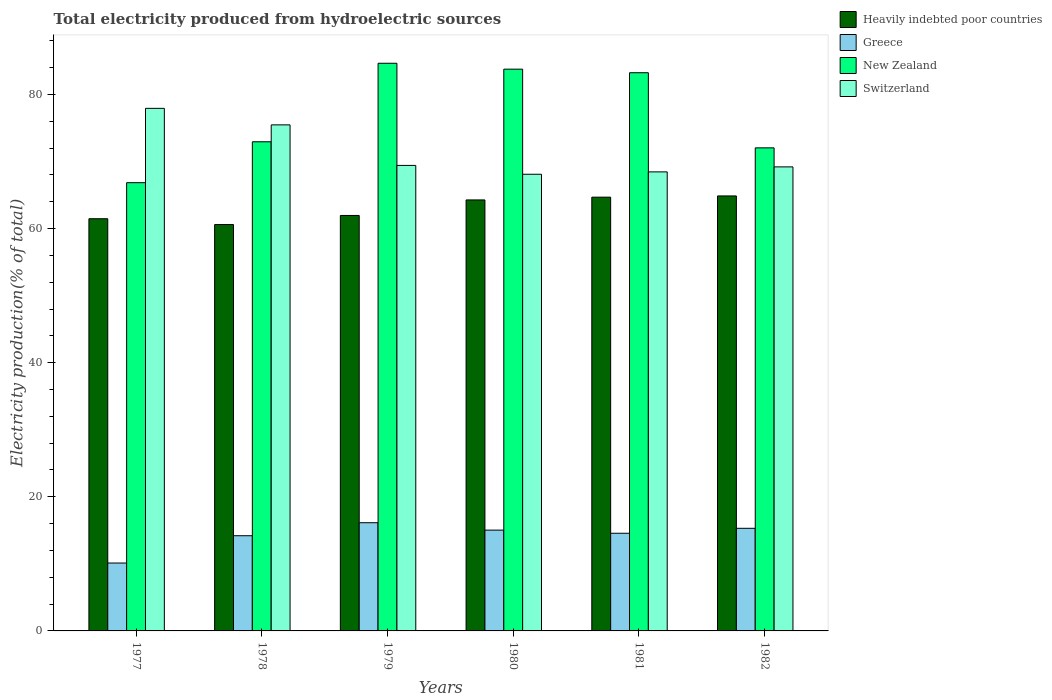Are the number of bars on each tick of the X-axis equal?
Your answer should be very brief. Yes. How many bars are there on the 1st tick from the right?
Give a very brief answer. 4. What is the label of the 2nd group of bars from the left?
Provide a short and direct response. 1978. In how many cases, is the number of bars for a given year not equal to the number of legend labels?
Make the answer very short. 0. What is the total electricity produced in Greece in 1981?
Provide a succinct answer. 14.56. Across all years, what is the maximum total electricity produced in New Zealand?
Offer a very short reply. 84.65. Across all years, what is the minimum total electricity produced in Heavily indebted poor countries?
Your response must be concise. 60.6. In which year was the total electricity produced in Switzerland maximum?
Provide a short and direct response. 1977. What is the total total electricity produced in New Zealand in the graph?
Keep it short and to the point. 463.47. What is the difference between the total electricity produced in Switzerland in 1977 and that in 1982?
Provide a succinct answer. 8.73. What is the difference between the total electricity produced in Greece in 1978 and the total electricity produced in Switzerland in 1980?
Provide a succinct answer. -53.9. What is the average total electricity produced in Heavily indebted poor countries per year?
Your answer should be compact. 62.97. In the year 1979, what is the difference between the total electricity produced in Heavily indebted poor countries and total electricity produced in New Zealand?
Keep it short and to the point. -22.7. In how many years, is the total electricity produced in Heavily indebted poor countries greater than 44 %?
Provide a short and direct response. 6. What is the ratio of the total electricity produced in Heavily indebted poor countries in 1981 to that in 1982?
Ensure brevity in your answer.  1. What is the difference between the highest and the second highest total electricity produced in Greece?
Offer a terse response. 0.83. What is the difference between the highest and the lowest total electricity produced in Greece?
Provide a short and direct response. 6.01. Is it the case that in every year, the sum of the total electricity produced in Switzerland and total electricity produced in New Zealand is greater than the sum of total electricity produced in Greece and total electricity produced in Heavily indebted poor countries?
Offer a very short reply. No. What does the 4th bar from the left in 1979 represents?
Provide a short and direct response. Switzerland. What does the 4th bar from the right in 1981 represents?
Make the answer very short. Heavily indebted poor countries. Is it the case that in every year, the sum of the total electricity produced in Heavily indebted poor countries and total electricity produced in Switzerland is greater than the total electricity produced in New Zealand?
Your response must be concise. Yes. Are all the bars in the graph horizontal?
Provide a succinct answer. No. How many years are there in the graph?
Provide a succinct answer. 6. Does the graph contain any zero values?
Your answer should be compact. No. Does the graph contain grids?
Your answer should be compact. No. Where does the legend appear in the graph?
Provide a succinct answer. Top right. How are the legend labels stacked?
Ensure brevity in your answer.  Vertical. What is the title of the graph?
Keep it short and to the point. Total electricity produced from hydroelectric sources. What is the Electricity production(% of total) in Heavily indebted poor countries in 1977?
Offer a terse response. 61.46. What is the Electricity production(% of total) in Greece in 1977?
Give a very brief answer. 10.12. What is the Electricity production(% of total) of New Zealand in 1977?
Offer a terse response. 66.84. What is the Electricity production(% of total) of Switzerland in 1977?
Ensure brevity in your answer.  77.92. What is the Electricity production(% of total) of Heavily indebted poor countries in 1978?
Give a very brief answer. 60.6. What is the Electricity production(% of total) of Greece in 1978?
Make the answer very short. 14.19. What is the Electricity production(% of total) of New Zealand in 1978?
Provide a succinct answer. 72.94. What is the Electricity production(% of total) of Switzerland in 1978?
Your answer should be very brief. 75.46. What is the Electricity production(% of total) in Heavily indebted poor countries in 1979?
Ensure brevity in your answer.  61.95. What is the Electricity production(% of total) in Greece in 1979?
Offer a very short reply. 16.13. What is the Electricity production(% of total) in New Zealand in 1979?
Provide a succinct answer. 84.65. What is the Electricity production(% of total) in Switzerland in 1979?
Your answer should be compact. 69.41. What is the Electricity production(% of total) in Heavily indebted poor countries in 1980?
Your answer should be compact. 64.27. What is the Electricity production(% of total) of Greece in 1980?
Give a very brief answer. 15.03. What is the Electricity production(% of total) of New Zealand in 1980?
Your response must be concise. 83.77. What is the Electricity production(% of total) in Switzerland in 1980?
Offer a terse response. 68.1. What is the Electricity production(% of total) of Heavily indebted poor countries in 1981?
Ensure brevity in your answer.  64.68. What is the Electricity production(% of total) in Greece in 1981?
Make the answer very short. 14.56. What is the Electricity production(% of total) in New Zealand in 1981?
Your answer should be compact. 83.24. What is the Electricity production(% of total) of Switzerland in 1981?
Your response must be concise. 68.45. What is the Electricity production(% of total) of Heavily indebted poor countries in 1982?
Ensure brevity in your answer.  64.86. What is the Electricity production(% of total) in Greece in 1982?
Ensure brevity in your answer.  15.3. What is the Electricity production(% of total) in New Zealand in 1982?
Offer a terse response. 72.03. What is the Electricity production(% of total) of Switzerland in 1982?
Make the answer very short. 69.2. Across all years, what is the maximum Electricity production(% of total) in Heavily indebted poor countries?
Your response must be concise. 64.86. Across all years, what is the maximum Electricity production(% of total) in Greece?
Make the answer very short. 16.13. Across all years, what is the maximum Electricity production(% of total) in New Zealand?
Your answer should be compact. 84.65. Across all years, what is the maximum Electricity production(% of total) in Switzerland?
Your response must be concise. 77.92. Across all years, what is the minimum Electricity production(% of total) in Heavily indebted poor countries?
Make the answer very short. 60.6. Across all years, what is the minimum Electricity production(% of total) in Greece?
Your response must be concise. 10.12. Across all years, what is the minimum Electricity production(% of total) in New Zealand?
Keep it short and to the point. 66.84. Across all years, what is the minimum Electricity production(% of total) of Switzerland?
Provide a succinct answer. 68.1. What is the total Electricity production(% of total) of Heavily indebted poor countries in the graph?
Offer a very short reply. 377.83. What is the total Electricity production(% of total) in Greece in the graph?
Your answer should be very brief. 85.35. What is the total Electricity production(% of total) in New Zealand in the graph?
Your answer should be compact. 463.47. What is the total Electricity production(% of total) in Switzerland in the graph?
Your answer should be very brief. 428.54. What is the difference between the Electricity production(% of total) of Heavily indebted poor countries in 1977 and that in 1978?
Your answer should be very brief. 0.87. What is the difference between the Electricity production(% of total) in Greece in 1977 and that in 1978?
Provide a short and direct response. -4.07. What is the difference between the Electricity production(% of total) of New Zealand in 1977 and that in 1978?
Provide a short and direct response. -6.1. What is the difference between the Electricity production(% of total) in Switzerland in 1977 and that in 1978?
Your response must be concise. 2.46. What is the difference between the Electricity production(% of total) of Heavily indebted poor countries in 1977 and that in 1979?
Offer a very short reply. -0.49. What is the difference between the Electricity production(% of total) of Greece in 1977 and that in 1979?
Provide a succinct answer. -6.01. What is the difference between the Electricity production(% of total) of New Zealand in 1977 and that in 1979?
Your answer should be very brief. -17.81. What is the difference between the Electricity production(% of total) in Switzerland in 1977 and that in 1979?
Give a very brief answer. 8.51. What is the difference between the Electricity production(% of total) in Heavily indebted poor countries in 1977 and that in 1980?
Provide a short and direct response. -2.8. What is the difference between the Electricity production(% of total) in Greece in 1977 and that in 1980?
Your response must be concise. -4.91. What is the difference between the Electricity production(% of total) in New Zealand in 1977 and that in 1980?
Provide a short and direct response. -16.93. What is the difference between the Electricity production(% of total) in Switzerland in 1977 and that in 1980?
Give a very brief answer. 9.83. What is the difference between the Electricity production(% of total) of Heavily indebted poor countries in 1977 and that in 1981?
Your response must be concise. -3.22. What is the difference between the Electricity production(% of total) in Greece in 1977 and that in 1981?
Ensure brevity in your answer.  -4.44. What is the difference between the Electricity production(% of total) in New Zealand in 1977 and that in 1981?
Your answer should be very brief. -16.4. What is the difference between the Electricity production(% of total) in Switzerland in 1977 and that in 1981?
Your answer should be compact. 9.47. What is the difference between the Electricity production(% of total) in Heavily indebted poor countries in 1977 and that in 1982?
Offer a very short reply. -3.4. What is the difference between the Electricity production(% of total) in Greece in 1977 and that in 1982?
Provide a short and direct response. -5.18. What is the difference between the Electricity production(% of total) of New Zealand in 1977 and that in 1982?
Provide a succinct answer. -5.19. What is the difference between the Electricity production(% of total) in Switzerland in 1977 and that in 1982?
Keep it short and to the point. 8.73. What is the difference between the Electricity production(% of total) in Heavily indebted poor countries in 1978 and that in 1979?
Give a very brief answer. -1.35. What is the difference between the Electricity production(% of total) in Greece in 1978 and that in 1979?
Make the answer very short. -1.94. What is the difference between the Electricity production(% of total) of New Zealand in 1978 and that in 1979?
Provide a succinct answer. -11.71. What is the difference between the Electricity production(% of total) of Switzerland in 1978 and that in 1979?
Ensure brevity in your answer.  6.05. What is the difference between the Electricity production(% of total) in Heavily indebted poor countries in 1978 and that in 1980?
Offer a terse response. -3.67. What is the difference between the Electricity production(% of total) of Greece in 1978 and that in 1980?
Provide a succinct answer. -0.84. What is the difference between the Electricity production(% of total) of New Zealand in 1978 and that in 1980?
Your answer should be very brief. -10.83. What is the difference between the Electricity production(% of total) in Switzerland in 1978 and that in 1980?
Your answer should be very brief. 7.36. What is the difference between the Electricity production(% of total) of Heavily indebted poor countries in 1978 and that in 1981?
Offer a terse response. -4.08. What is the difference between the Electricity production(% of total) in Greece in 1978 and that in 1981?
Your answer should be very brief. -0.37. What is the difference between the Electricity production(% of total) of New Zealand in 1978 and that in 1981?
Keep it short and to the point. -10.3. What is the difference between the Electricity production(% of total) of Switzerland in 1978 and that in 1981?
Your response must be concise. 7.01. What is the difference between the Electricity production(% of total) of Heavily indebted poor countries in 1978 and that in 1982?
Provide a short and direct response. -4.27. What is the difference between the Electricity production(% of total) of Greece in 1978 and that in 1982?
Provide a short and direct response. -1.11. What is the difference between the Electricity production(% of total) of New Zealand in 1978 and that in 1982?
Ensure brevity in your answer.  0.9. What is the difference between the Electricity production(% of total) of Switzerland in 1978 and that in 1982?
Ensure brevity in your answer.  6.27. What is the difference between the Electricity production(% of total) in Heavily indebted poor countries in 1979 and that in 1980?
Offer a terse response. -2.32. What is the difference between the Electricity production(% of total) in Greece in 1979 and that in 1980?
Your answer should be compact. 1.1. What is the difference between the Electricity production(% of total) in New Zealand in 1979 and that in 1980?
Keep it short and to the point. 0.88. What is the difference between the Electricity production(% of total) of Switzerland in 1979 and that in 1980?
Provide a short and direct response. 1.32. What is the difference between the Electricity production(% of total) in Heavily indebted poor countries in 1979 and that in 1981?
Provide a short and direct response. -2.73. What is the difference between the Electricity production(% of total) of Greece in 1979 and that in 1981?
Offer a very short reply. 1.57. What is the difference between the Electricity production(% of total) of New Zealand in 1979 and that in 1981?
Provide a succinct answer. 1.41. What is the difference between the Electricity production(% of total) of Switzerland in 1979 and that in 1981?
Ensure brevity in your answer.  0.96. What is the difference between the Electricity production(% of total) of Heavily indebted poor countries in 1979 and that in 1982?
Make the answer very short. -2.91. What is the difference between the Electricity production(% of total) of Greece in 1979 and that in 1982?
Your answer should be compact. 0.83. What is the difference between the Electricity production(% of total) of New Zealand in 1979 and that in 1982?
Offer a very short reply. 12.61. What is the difference between the Electricity production(% of total) of Switzerland in 1979 and that in 1982?
Your answer should be very brief. 0.22. What is the difference between the Electricity production(% of total) of Heavily indebted poor countries in 1980 and that in 1981?
Your answer should be very brief. -0.41. What is the difference between the Electricity production(% of total) in Greece in 1980 and that in 1981?
Give a very brief answer. 0.47. What is the difference between the Electricity production(% of total) in New Zealand in 1980 and that in 1981?
Your response must be concise. 0.53. What is the difference between the Electricity production(% of total) in Switzerland in 1980 and that in 1981?
Offer a very short reply. -0.36. What is the difference between the Electricity production(% of total) of Heavily indebted poor countries in 1980 and that in 1982?
Offer a very short reply. -0.59. What is the difference between the Electricity production(% of total) in Greece in 1980 and that in 1982?
Ensure brevity in your answer.  -0.27. What is the difference between the Electricity production(% of total) of New Zealand in 1980 and that in 1982?
Your answer should be compact. 11.73. What is the difference between the Electricity production(% of total) of Switzerland in 1980 and that in 1982?
Give a very brief answer. -1.1. What is the difference between the Electricity production(% of total) in Heavily indebted poor countries in 1981 and that in 1982?
Make the answer very short. -0.18. What is the difference between the Electricity production(% of total) in Greece in 1981 and that in 1982?
Your response must be concise. -0.74. What is the difference between the Electricity production(% of total) in New Zealand in 1981 and that in 1982?
Provide a short and direct response. 11.2. What is the difference between the Electricity production(% of total) in Switzerland in 1981 and that in 1982?
Ensure brevity in your answer.  -0.74. What is the difference between the Electricity production(% of total) of Heavily indebted poor countries in 1977 and the Electricity production(% of total) of Greece in 1978?
Offer a very short reply. 47.27. What is the difference between the Electricity production(% of total) in Heavily indebted poor countries in 1977 and the Electricity production(% of total) in New Zealand in 1978?
Your response must be concise. -11.47. What is the difference between the Electricity production(% of total) in Heavily indebted poor countries in 1977 and the Electricity production(% of total) in Switzerland in 1978?
Your response must be concise. -14. What is the difference between the Electricity production(% of total) in Greece in 1977 and the Electricity production(% of total) in New Zealand in 1978?
Offer a very short reply. -62.82. What is the difference between the Electricity production(% of total) in Greece in 1977 and the Electricity production(% of total) in Switzerland in 1978?
Make the answer very short. -65.34. What is the difference between the Electricity production(% of total) of New Zealand in 1977 and the Electricity production(% of total) of Switzerland in 1978?
Provide a short and direct response. -8.62. What is the difference between the Electricity production(% of total) of Heavily indebted poor countries in 1977 and the Electricity production(% of total) of Greece in 1979?
Offer a terse response. 45.33. What is the difference between the Electricity production(% of total) in Heavily indebted poor countries in 1977 and the Electricity production(% of total) in New Zealand in 1979?
Offer a terse response. -23.18. What is the difference between the Electricity production(% of total) of Heavily indebted poor countries in 1977 and the Electricity production(% of total) of Switzerland in 1979?
Give a very brief answer. -7.95. What is the difference between the Electricity production(% of total) in Greece in 1977 and the Electricity production(% of total) in New Zealand in 1979?
Ensure brevity in your answer.  -74.52. What is the difference between the Electricity production(% of total) of Greece in 1977 and the Electricity production(% of total) of Switzerland in 1979?
Ensure brevity in your answer.  -59.29. What is the difference between the Electricity production(% of total) of New Zealand in 1977 and the Electricity production(% of total) of Switzerland in 1979?
Keep it short and to the point. -2.57. What is the difference between the Electricity production(% of total) in Heavily indebted poor countries in 1977 and the Electricity production(% of total) in Greece in 1980?
Provide a succinct answer. 46.43. What is the difference between the Electricity production(% of total) in Heavily indebted poor countries in 1977 and the Electricity production(% of total) in New Zealand in 1980?
Your answer should be very brief. -22.3. What is the difference between the Electricity production(% of total) in Heavily indebted poor countries in 1977 and the Electricity production(% of total) in Switzerland in 1980?
Your response must be concise. -6.63. What is the difference between the Electricity production(% of total) of Greece in 1977 and the Electricity production(% of total) of New Zealand in 1980?
Make the answer very short. -73.64. What is the difference between the Electricity production(% of total) of Greece in 1977 and the Electricity production(% of total) of Switzerland in 1980?
Make the answer very short. -57.97. What is the difference between the Electricity production(% of total) in New Zealand in 1977 and the Electricity production(% of total) in Switzerland in 1980?
Your response must be concise. -1.25. What is the difference between the Electricity production(% of total) in Heavily indebted poor countries in 1977 and the Electricity production(% of total) in Greece in 1981?
Offer a very short reply. 46.9. What is the difference between the Electricity production(% of total) of Heavily indebted poor countries in 1977 and the Electricity production(% of total) of New Zealand in 1981?
Provide a succinct answer. -21.77. What is the difference between the Electricity production(% of total) of Heavily indebted poor countries in 1977 and the Electricity production(% of total) of Switzerland in 1981?
Make the answer very short. -6.99. What is the difference between the Electricity production(% of total) of Greece in 1977 and the Electricity production(% of total) of New Zealand in 1981?
Give a very brief answer. -73.11. What is the difference between the Electricity production(% of total) of Greece in 1977 and the Electricity production(% of total) of Switzerland in 1981?
Your answer should be compact. -58.33. What is the difference between the Electricity production(% of total) in New Zealand in 1977 and the Electricity production(% of total) in Switzerland in 1981?
Make the answer very short. -1.61. What is the difference between the Electricity production(% of total) of Heavily indebted poor countries in 1977 and the Electricity production(% of total) of Greece in 1982?
Your answer should be compact. 46.16. What is the difference between the Electricity production(% of total) of Heavily indebted poor countries in 1977 and the Electricity production(% of total) of New Zealand in 1982?
Offer a terse response. -10.57. What is the difference between the Electricity production(% of total) of Heavily indebted poor countries in 1977 and the Electricity production(% of total) of Switzerland in 1982?
Your answer should be compact. -7.73. What is the difference between the Electricity production(% of total) of Greece in 1977 and the Electricity production(% of total) of New Zealand in 1982?
Ensure brevity in your answer.  -61.91. What is the difference between the Electricity production(% of total) of Greece in 1977 and the Electricity production(% of total) of Switzerland in 1982?
Your response must be concise. -59.07. What is the difference between the Electricity production(% of total) of New Zealand in 1977 and the Electricity production(% of total) of Switzerland in 1982?
Keep it short and to the point. -2.35. What is the difference between the Electricity production(% of total) in Heavily indebted poor countries in 1978 and the Electricity production(% of total) in Greece in 1979?
Ensure brevity in your answer.  44.46. What is the difference between the Electricity production(% of total) in Heavily indebted poor countries in 1978 and the Electricity production(% of total) in New Zealand in 1979?
Make the answer very short. -24.05. What is the difference between the Electricity production(% of total) in Heavily indebted poor countries in 1978 and the Electricity production(% of total) in Switzerland in 1979?
Offer a terse response. -8.82. What is the difference between the Electricity production(% of total) in Greece in 1978 and the Electricity production(% of total) in New Zealand in 1979?
Provide a succinct answer. -70.45. What is the difference between the Electricity production(% of total) in Greece in 1978 and the Electricity production(% of total) in Switzerland in 1979?
Make the answer very short. -55.22. What is the difference between the Electricity production(% of total) in New Zealand in 1978 and the Electricity production(% of total) in Switzerland in 1979?
Provide a succinct answer. 3.53. What is the difference between the Electricity production(% of total) of Heavily indebted poor countries in 1978 and the Electricity production(% of total) of Greece in 1980?
Make the answer very short. 45.57. What is the difference between the Electricity production(% of total) in Heavily indebted poor countries in 1978 and the Electricity production(% of total) in New Zealand in 1980?
Your response must be concise. -23.17. What is the difference between the Electricity production(% of total) in Heavily indebted poor countries in 1978 and the Electricity production(% of total) in Switzerland in 1980?
Make the answer very short. -7.5. What is the difference between the Electricity production(% of total) of Greece in 1978 and the Electricity production(% of total) of New Zealand in 1980?
Your answer should be compact. -69.57. What is the difference between the Electricity production(% of total) of Greece in 1978 and the Electricity production(% of total) of Switzerland in 1980?
Your answer should be very brief. -53.9. What is the difference between the Electricity production(% of total) in New Zealand in 1978 and the Electricity production(% of total) in Switzerland in 1980?
Give a very brief answer. 4.84. What is the difference between the Electricity production(% of total) in Heavily indebted poor countries in 1978 and the Electricity production(% of total) in Greece in 1981?
Ensure brevity in your answer.  46.03. What is the difference between the Electricity production(% of total) of Heavily indebted poor countries in 1978 and the Electricity production(% of total) of New Zealand in 1981?
Your answer should be compact. -22.64. What is the difference between the Electricity production(% of total) of Heavily indebted poor countries in 1978 and the Electricity production(% of total) of Switzerland in 1981?
Ensure brevity in your answer.  -7.85. What is the difference between the Electricity production(% of total) in Greece in 1978 and the Electricity production(% of total) in New Zealand in 1981?
Provide a succinct answer. -69.04. What is the difference between the Electricity production(% of total) of Greece in 1978 and the Electricity production(% of total) of Switzerland in 1981?
Your answer should be compact. -54.26. What is the difference between the Electricity production(% of total) in New Zealand in 1978 and the Electricity production(% of total) in Switzerland in 1981?
Your response must be concise. 4.49. What is the difference between the Electricity production(% of total) in Heavily indebted poor countries in 1978 and the Electricity production(% of total) in Greece in 1982?
Keep it short and to the point. 45.3. What is the difference between the Electricity production(% of total) of Heavily indebted poor countries in 1978 and the Electricity production(% of total) of New Zealand in 1982?
Provide a short and direct response. -11.44. What is the difference between the Electricity production(% of total) of Heavily indebted poor countries in 1978 and the Electricity production(% of total) of Switzerland in 1982?
Offer a very short reply. -8.6. What is the difference between the Electricity production(% of total) of Greece in 1978 and the Electricity production(% of total) of New Zealand in 1982?
Your response must be concise. -57.84. What is the difference between the Electricity production(% of total) of Greece in 1978 and the Electricity production(% of total) of Switzerland in 1982?
Offer a terse response. -55. What is the difference between the Electricity production(% of total) in New Zealand in 1978 and the Electricity production(% of total) in Switzerland in 1982?
Give a very brief answer. 3.74. What is the difference between the Electricity production(% of total) of Heavily indebted poor countries in 1979 and the Electricity production(% of total) of Greece in 1980?
Offer a very short reply. 46.92. What is the difference between the Electricity production(% of total) in Heavily indebted poor countries in 1979 and the Electricity production(% of total) in New Zealand in 1980?
Your answer should be very brief. -21.82. What is the difference between the Electricity production(% of total) in Heavily indebted poor countries in 1979 and the Electricity production(% of total) in Switzerland in 1980?
Make the answer very short. -6.14. What is the difference between the Electricity production(% of total) of Greece in 1979 and the Electricity production(% of total) of New Zealand in 1980?
Your response must be concise. -67.63. What is the difference between the Electricity production(% of total) in Greece in 1979 and the Electricity production(% of total) in Switzerland in 1980?
Provide a short and direct response. -51.96. What is the difference between the Electricity production(% of total) of New Zealand in 1979 and the Electricity production(% of total) of Switzerland in 1980?
Provide a succinct answer. 16.55. What is the difference between the Electricity production(% of total) of Heavily indebted poor countries in 1979 and the Electricity production(% of total) of Greece in 1981?
Your response must be concise. 47.39. What is the difference between the Electricity production(% of total) in Heavily indebted poor countries in 1979 and the Electricity production(% of total) in New Zealand in 1981?
Your answer should be very brief. -21.28. What is the difference between the Electricity production(% of total) of Heavily indebted poor countries in 1979 and the Electricity production(% of total) of Switzerland in 1981?
Give a very brief answer. -6.5. What is the difference between the Electricity production(% of total) of Greece in 1979 and the Electricity production(% of total) of New Zealand in 1981?
Your answer should be very brief. -67.1. What is the difference between the Electricity production(% of total) in Greece in 1979 and the Electricity production(% of total) in Switzerland in 1981?
Your answer should be compact. -52.32. What is the difference between the Electricity production(% of total) in New Zealand in 1979 and the Electricity production(% of total) in Switzerland in 1981?
Ensure brevity in your answer.  16.2. What is the difference between the Electricity production(% of total) of Heavily indebted poor countries in 1979 and the Electricity production(% of total) of Greece in 1982?
Give a very brief answer. 46.65. What is the difference between the Electricity production(% of total) of Heavily indebted poor countries in 1979 and the Electricity production(% of total) of New Zealand in 1982?
Your answer should be very brief. -10.08. What is the difference between the Electricity production(% of total) in Heavily indebted poor countries in 1979 and the Electricity production(% of total) in Switzerland in 1982?
Your response must be concise. -7.24. What is the difference between the Electricity production(% of total) in Greece in 1979 and the Electricity production(% of total) in New Zealand in 1982?
Make the answer very short. -55.9. What is the difference between the Electricity production(% of total) of Greece in 1979 and the Electricity production(% of total) of Switzerland in 1982?
Your response must be concise. -53.06. What is the difference between the Electricity production(% of total) of New Zealand in 1979 and the Electricity production(% of total) of Switzerland in 1982?
Make the answer very short. 15.45. What is the difference between the Electricity production(% of total) of Heavily indebted poor countries in 1980 and the Electricity production(% of total) of Greece in 1981?
Offer a terse response. 49.7. What is the difference between the Electricity production(% of total) of Heavily indebted poor countries in 1980 and the Electricity production(% of total) of New Zealand in 1981?
Keep it short and to the point. -18.97. What is the difference between the Electricity production(% of total) in Heavily indebted poor countries in 1980 and the Electricity production(% of total) in Switzerland in 1981?
Your response must be concise. -4.18. What is the difference between the Electricity production(% of total) of Greece in 1980 and the Electricity production(% of total) of New Zealand in 1981?
Ensure brevity in your answer.  -68.21. What is the difference between the Electricity production(% of total) of Greece in 1980 and the Electricity production(% of total) of Switzerland in 1981?
Offer a very short reply. -53.42. What is the difference between the Electricity production(% of total) in New Zealand in 1980 and the Electricity production(% of total) in Switzerland in 1981?
Give a very brief answer. 15.32. What is the difference between the Electricity production(% of total) of Heavily indebted poor countries in 1980 and the Electricity production(% of total) of Greece in 1982?
Keep it short and to the point. 48.97. What is the difference between the Electricity production(% of total) of Heavily indebted poor countries in 1980 and the Electricity production(% of total) of New Zealand in 1982?
Make the answer very short. -7.77. What is the difference between the Electricity production(% of total) of Heavily indebted poor countries in 1980 and the Electricity production(% of total) of Switzerland in 1982?
Give a very brief answer. -4.93. What is the difference between the Electricity production(% of total) in Greece in 1980 and the Electricity production(% of total) in New Zealand in 1982?
Provide a short and direct response. -57. What is the difference between the Electricity production(% of total) in Greece in 1980 and the Electricity production(% of total) in Switzerland in 1982?
Your answer should be very brief. -54.16. What is the difference between the Electricity production(% of total) in New Zealand in 1980 and the Electricity production(% of total) in Switzerland in 1982?
Provide a succinct answer. 14.57. What is the difference between the Electricity production(% of total) of Heavily indebted poor countries in 1981 and the Electricity production(% of total) of Greece in 1982?
Offer a very short reply. 49.38. What is the difference between the Electricity production(% of total) in Heavily indebted poor countries in 1981 and the Electricity production(% of total) in New Zealand in 1982?
Offer a terse response. -7.35. What is the difference between the Electricity production(% of total) of Heavily indebted poor countries in 1981 and the Electricity production(% of total) of Switzerland in 1982?
Keep it short and to the point. -4.51. What is the difference between the Electricity production(% of total) in Greece in 1981 and the Electricity production(% of total) in New Zealand in 1982?
Your answer should be very brief. -57.47. What is the difference between the Electricity production(% of total) of Greece in 1981 and the Electricity production(% of total) of Switzerland in 1982?
Your answer should be very brief. -54.63. What is the difference between the Electricity production(% of total) of New Zealand in 1981 and the Electricity production(% of total) of Switzerland in 1982?
Provide a succinct answer. 14.04. What is the average Electricity production(% of total) of Heavily indebted poor countries per year?
Give a very brief answer. 62.97. What is the average Electricity production(% of total) of Greece per year?
Provide a short and direct response. 14.22. What is the average Electricity production(% of total) in New Zealand per year?
Make the answer very short. 77.24. What is the average Electricity production(% of total) in Switzerland per year?
Offer a terse response. 71.42. In the year 1977, what is the difference between the Electricity production(% of total) in Heavily indebted poor countries and Electricity production(% of total) in Greece?
Make the answer very short. 51.34. In the year 1977, what is the difference between the Electricity production(% of total) of Heavily indebted poor countries and Electricity production(% of total) of New Zealand?
Provide a short and direct response. -5.38. In the year 1977, what is the difference between the Electricity production(% of total) of Heavily indebted poor countries and Electricity production(% of total) of Switzerland?
Keep it short and to the point. -16.46. In the year 1977, what is the difference between the Electricity production(% of total) in Greece and Electricity production(% of total) in New Zealand?
Give a very brief answer. -56.72. In the year 1977, what is the difference between the Electricity production(% of total) of Greece and Electricity production(% of total) of Switzerland?
Offer a very short reply. -67.8. In the year 1977, what is the difference between the Electricity production(% of total) of New Zealand and Electricity production(% of total) of Switzerland?
Your response must be concise. -11.08. In the year 1978, what is the difference between the Electricity production(% of total) in Heavily indebted poor countries and Electricity production(% of total) in Greece?
Your response must be concise. 46.4. In the year 1978, what is the difference between the Electricity production(% of total) in Heavily indebted poor countries and Electricity production(% of total) in New Zealand?
Give a very brief answer. -12.34. In the year 1978, what is the difference between the Electricity production(% of total) in Heavily indebted poor countries and Electricity production(% of total) in Switzerland?
Provide a short and direct response. -14.86. In the year 1978, what is the difference between the Electricity production(% of total) of Greece and Electricity production(% of total) of New Zealand?
Your response must be concise. -58.74. In the year 1978, what is the difference between the Electricity production(% of total) of Greece and Electricity production(% of total) of Switzerland?
Your answer should be compact. -61.27. In the year 1978, what is the difference between the Electricity production(% of total) of New Zealand and Electricity production(% of total) of Switzerland?
Give a very brief answer. -2.52. In the year 1979, what is the difference between the Electricity production(% of total) of Heavily indebted poor countries and Electricity production(% of total) of Greece?
Make the answer very short. 45.82. In the year 1979, what is the difference between the Electricity production(% of total) of Heavily indebted poor countries and Electricity production(% of total) of New Zealand?
Keep it short and to the point. -22.7. In the year 1979, what is the difference between the Electricity production(% of total) in Heavily indebted poor countries and Electricity production(% of total) in Switzerland?
Your answer should be compact. -7.46. In the year 1979, what is the difference between the Electricity production(% of total) in Greece and Electricity production(% of total) in New Zealand?
Offer a terse response. -68.51. In the year 1979, what is the difference between the Electricity production(% of total) of Greece and Electricity production(% of total) of Switzerland?
Keep it short and to the point. -53.28. In the year 1979, what is the difference between the Electricity production(% of total) of New Zealand and Electricity production(% of total) of Switzerland?
Make the answer very short. 15.23. In the year 1980, what is the difference between the Electricity production(% of total) in Heavily indebted poor countries and Electricity production(% of total) in Greece?
Offer a terse response. 49.24. In the year 1980, what is the difference between the Electricity production(% of total) of Heavily indebted poor countries and Electricity production(% of total) of New Zealand?
Provide a short and direct response. -19.5. In the year 1980, what is the difference between the Electricity production(% of total) in Heavily indebted poor countries and Electricity production(% of total) in Switzerland?
Offer a terse response. -3.83. In the year 1980, what is the difference between the Electricity production(% of total) in Greece and Electricity production(% of total) in New Zealand?
Your answer should be very brief. -68.74. In the year 1980, what is the difference between the Electricity production(% of total) of Greece and Electricity production(% of total) of Switzerland?
Your answer should be very brief. -53.06. In the year 1980, what is the difference between the Electricity production(% of total) in New Zealand and Electricity production(% of total) in Switzerland?
Offer a very short reply. 15.67. In the year 1981, what is the difference between the Electricity production(% of total) in Heavily indebted poor countries and Electricity production(% of total) in Greece?
Keep it short and to the point. 50.12. In the year 1981, what is the difference between the Electricity production(% of total) in Heavily indebted poor countries and Electricity production(% of total) in New Zealand?
Your answer should be very brief. -18.56. In the year 1981, what is the difference between the Electricity production(% of total) in Heavily indebted poor countries and Electricity production(% of total) in Switzerland?
Keep it short and to the point. -3.77. In the year 1981, what is the difference between the Electricity production(% of total) of Greece and Electricity production(% of total) of New Zealand?
Your answer should be very brief. -68.67. In the year 1981, what is the difference between the Electricity production(% of total) of Greece and Electricity production(% of total) of Switzerland?
Your response must be concise. -53.89. In the year 1981, what is the difference between the Electricity production(% of total) in New Zealand and Electricity production(% of total) in Switzerland?
Your answer should be compact. 14.79. In the year 1982, what is the difference between the Electricity production(% of total) of Heavily indebted poor countries and Electricity production(% of total) of Greece?
Provide a succinct answer. 49.56. In the year 1982, what is the difference between the Electricity production(% of total) in Heavily indebted poor countries and Electricity production(% of total) in New Zealand?
Your answer should be compact. -7.17. In the year 1982, what is the difference between the Electricity production(% of total) of Heavily indebted poor countries and Electricity production(% of total) of Switzerland?
Your answer should be compact. -4.33. In the year 1982, what is the difference between the Electricity production(% of total) of Greece and Electricity production(% of total) of New Zealand?
Your response must be concise. -56.73. In the year 1982, what is the difference between the Electricity production(% of total) in Greece and Electricity production(% of total) in Switzerland?
Your response must be concise. -53.89. In the year 1982, what is the difference between the Electricity production(% of total) of New Zealand and Electricity production(% of total) of Switzerland?
Your answer should be compact. 2.84. What is the ratio of the Electricity production(% of total) of Heavily indebted poor countries in 1977 to that in 1978?
Give a very brief answer. 1.01. What is the ratio of the Electricity production(% of total) in Greece in 1977 to that in 1978?
Your answer should be very brief. 0.71. What is the ratio of the Electricity production(% of total) of New Zealand in 1977 to that in 1978?
Provide a succinct answer. 0.92. What is the ratio of the Electricity production(% of total) in Switzerland in 1977 to that in 1978?
Your response must be concise. 1.03. What is the ratio of the Electricity production(% of total) of Greece in 1977 to that in 1979?
Give a very brief answer. 0.63. What is the ratio of the Electricity production(% of total) of New Zealand in 1977 to that in 1979?
Provide a succinct answer. 0.79. What is the ratio of the Electricity production(% of total) of Switzerland in 1977 to that in 1979?
Ensure brevity in your answer.  1.12. What is the ratio of the Electricity production(% of total) in Heavily indebted poor countries in 1977 to that in 1980?
Provide a short and direct response. 0.96. What is the ratio of the Electricity production(% of total) in Greece in 1977 to that in 1980?
Offer a terse response. 0.67. What is the ratio of the Electricity production(% of total) of New Zealand in 1977 to that in 1980?
Give a very brief answer. 0.8. What is the ratio of the Electricity production(% of total) in Switzerland in 1977 to that in 1980?
Provide a short and direct response. 1.14. What is the ratio of the Electricity production(% of total) in Heavily indebted poor countries in 1977 to that in 1981?
Ensure brevity in your answer.  0.95. What is the ratio of the Electricity production(% of total) in Greece in 1977 to that in 1981?
Offer a terse response. 0.7. What is the ratio of the Electricity production(% of total) of New Zealand in 1977 to that in 1981?
Offer a terse response. 0.8. What is the ratio of the Electricity production(% of total) of Switzerland in 1977 to that in 1981?
Your answer should be compact. 1.14. What is the ratio of the Electricity production(% of total) in Heavily indebted poor countries in 1977 to that in 1982?
Make the answer very short. 0.95. What is the ratio of the Electricity production(% of total) in Greece in 1977 to that in 1982?
Give a very brief answer. 0.66. What is the ratio of the Electricity production(% of total) of New Zealand in 1977 to that in 1982?
Your answer should be very brief. 0.93. What is the ratio of the Electricity production(% of total) in Switzerland in 1977 to that in 1982?
Offer a very short reply. 1.13. What is the ratio of the Electricity production(% of total) of Heavily indebted poor countries in 1978 to that in 1979?
Provide a short and direct response. 0.98. What is the ratio of the Electricity production(% of total) in Greece in 1978 to that in 1979?
Provide a short and direct response. 0.88. What is the ratio of the Electricity production(% of total) in New Zealand in 1978 to that in 1979?
Offer a very short reply. 0.86. What is the ratio of the Electricity production(% of total) of Switzerland in 1978 to that in 1979?
Provide a short and direct response. 1.09. What is the ratio of the Electricity production(% of total) in Heavily indebted poor countries in 1978 to that in 1980?
Give a very brief answer. 0.94. What is the ratio of the Electricity production(% of total) in New Zealand in 1978 to that in 1980?
Your response must be concise. 0.87. What is the ratio of the Electricity production(% of total) of Switzerland in 1978 to that in 1980?
Offer a very short reply. 1.11. What is the ratio of the Electricity production(% of total) of Heavily indebted poor countries in 1978 to that in 1981?
Your answer should be compact. 0.94. What is the ratio of the Electricity production(% of total) in Greece in 1978 to that in 1981?
Your answer should be compact. 0.97. What is the ratio of the Electricity production(% of total) of New Zealand in 1978 to that in 1981?
Offer a terse response. 0.88. What is the ratio of the Electricity production(% of total) in Switzerland in 1978 to that in 1981?
Give a very brief answer. 1.1. What is the ratio of the Electricity production(% of total) of Heavily indebted poor countries in 1978 to that in 1982?
Provide a succinct answer. 0.93. What is the ratio of the Electricity production(% of total) in Greece in 1978 to that in 1982?
Give a very brief answer. 0.93. What is the ratio of the Electricity production(% of total) in New Zealand in 1978 to that in 1982?
Give a very brief answer. 1.01. What is the ratio of the Electricity production(% of total) of Switzerland in 1978 to that in 1982?
Make the answer very short. 1.09. What is the ratio of the Electricity production(% of total) in Greece in 1979 to that in 1980?
Make the answer very short. 1.07. What is the ratio of the Electricity production(% of total) of New Zealand in 1979 to that in 1980?
Ensure brevity in your answer.  1.01. What is the ratio of the Electricity production(% of total) of Switzerland in 1979 to that in 1980?
Offer a very short reply. 1.02. What is the ratio of the Electricity production(% of total) of Heavily indebted poor countries in 1979 to that in 1981?
Your response must be concise. 0.96. What is the ratio of the Electricity production(% of total) in Greece in 1979 to that in 1981?
Keep it short and to the point. 1.11. What is the ratio of the Electricity production(% of total) of Switzerland in 1979 to that in 1981?
Ensure brevity in your answer.  1.01. What is the ratio of the Electricity production(% of total) in Heavily indebted poor countries in 1979 to that in 1982?
Offer a very short reply. 0.96. What is the ratio of the Electricity production(% of total) in Greece in 1979 to that in 1982?
Provide a succinct answer. 1.05. What is the ratio of the Electricity production(% of total) in New Zealand in 1979 to that in 1982?
Ensure brevity in your answer.  1.18. What is the ratio of the Electricity production(% of total) in Heavily indebted poor countries in 1980 to that in 1981?
Give a very brief answer. 0.99. What is the ratio of the Electricity production(% of total) of Greece in 1980 to that in 1981?
Give a very brief answer. 1.03. What is the ratio of the Electricity production(% of total) in New Zealand in 1980 to that in 1981?
Make the answer very short. 1.01. What is the ratio of the Electricity production(% of total) of Switzerland in 1980 to that in 1981?
Keep it short and to the point. 0.99. What is the ratio of the Electricity production(% of total) of Heavily indebted poor countries in 1980 to that in 1982?
Keep it short and to the point. 0.99. What is the ratio of the Electricity production(% of total) in Greece in 1980 to that in 1982?
Provide a succinct answer. 0.98. What is the ratio of the Electricity production(% of total) in New Zealand in 1980 to that in 1982?
Keep it short and to the point. 1.16. What is the ratio of the Electricity production(% of total) of Switzerland in 1980 to that in 1982?
Provide a succinct answer. 0.98. What is the ratio of the Electricity production(% of total) in Greece in 1981 to that in 1982?
Provide a short and direct response. 0.95. What is the ratio of the Electricity production(% of total) in New Zealand in 1981 to that in 1982?
Keep it short and to the point. 1.16. What is the ratio of the Electricity production(% of total) in Switzerland in 1981 to that in 1982?
Offer a very short reply. 0.99. What is the difference between the highest and the second highest Electricity production(% of total) of Heavily indebted poor countries?
Offer a terse response. 0.18. What is the difference between the highest and the second highest Electricity production(% of total) in Greece?
Your answer should be compact. 0.83. What is the difference between the highest and the second highest Electricity production(% of total) of New Zealand?
Make the answer very short. 0.88. What is the difference between the highest and the second highest Electricity production(% of total) of Switzerland?
Provide a succinct answer. 2.46. What is the difference between the highest and the lowest Electricity production(% of total) of Heavily indebted poor countries?
Keep it short and to the point. 4.27. What is the difference between the highest and the lowest Electricity production(% of total) in Greece?
Make the answer very short. 6.01. What is the difference between the highest and the lowest Electricity production(% of total) of New Zealand?
Your response must be concise. 17.81. What is the difference between the highest and the lowest Electricity production(% of total) in Switzerland?
Give a very brief answer. 9.83. 